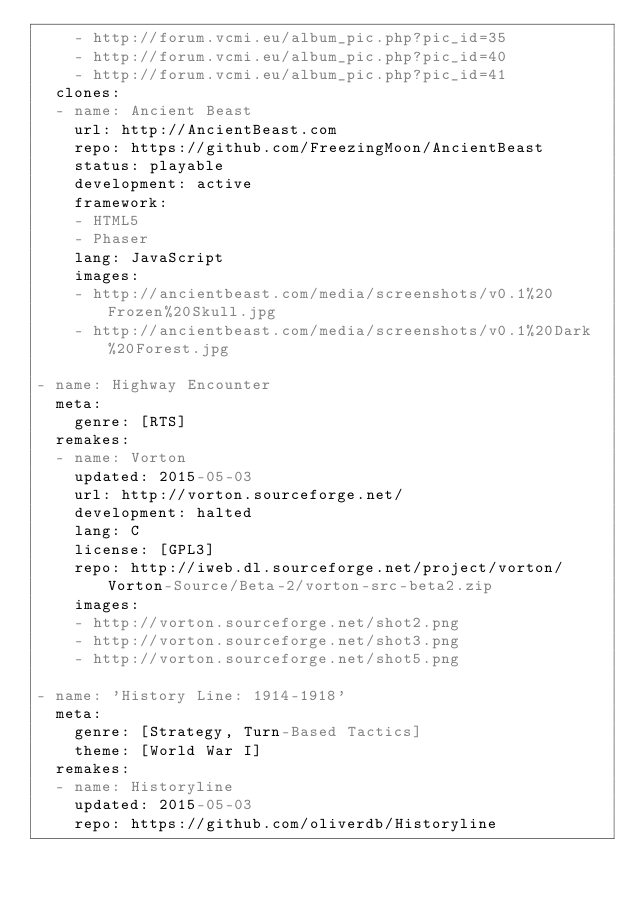<code> <loc_0><loc_0><loc_500><loc_500><_YAML_>    - http://forum.vcmi.eu/album_pic.php?pic_id=35
    - http://forum.vcmi.eu/album_pic.php?pic_id=40
    - http://forum.vcmi.eu/album_pic.php?pic_id=41
  clones:
  - name: Ancient Beast
    url: http://AncientBeast.com
    repo: https://github.com/FreezingMoon/AncientBeast
    status: playable
    development: active
    framework:
    - HTML5
    - Phaser
    lang: JavaScript
    images:
    - http://ancientbeast.com/media/screenshots/v0.1%20Frozen%20Skull.jpg
    - http://ancientbeast.com/media/screenshots/v0.1%20Dark%20Forest.jpg

- name: Highway Encounter
  meta:
    genre: [RTS]
  remakes:
  - name: Vorton
    updated: 2015-05-03
    url: http://vorton.sourceforge.net/
    development: halted
    lang: C
    license: [GPL3]
    repo: http://iweb.dl.sourceforge.net/project/vorton/Vorton-Source/Beta-2/vorton-src-beta2.zip
    images:
    - http://vorton.sourceforge.net/shot2.png
    - http://vorton.sourceforge.net/shot3.png
    - http://vorton.sourceforge.net/shot5.png

- name: 'History Line: 1914-1918'
  meta:
    genre: [Strategy, Turn-Based Tactics]
    theme: [World War I]
  remakes:
  - name: Historyline
    updated: 2015-05-03
    repo: https://github.com/oliverdb/Historyline</code> 